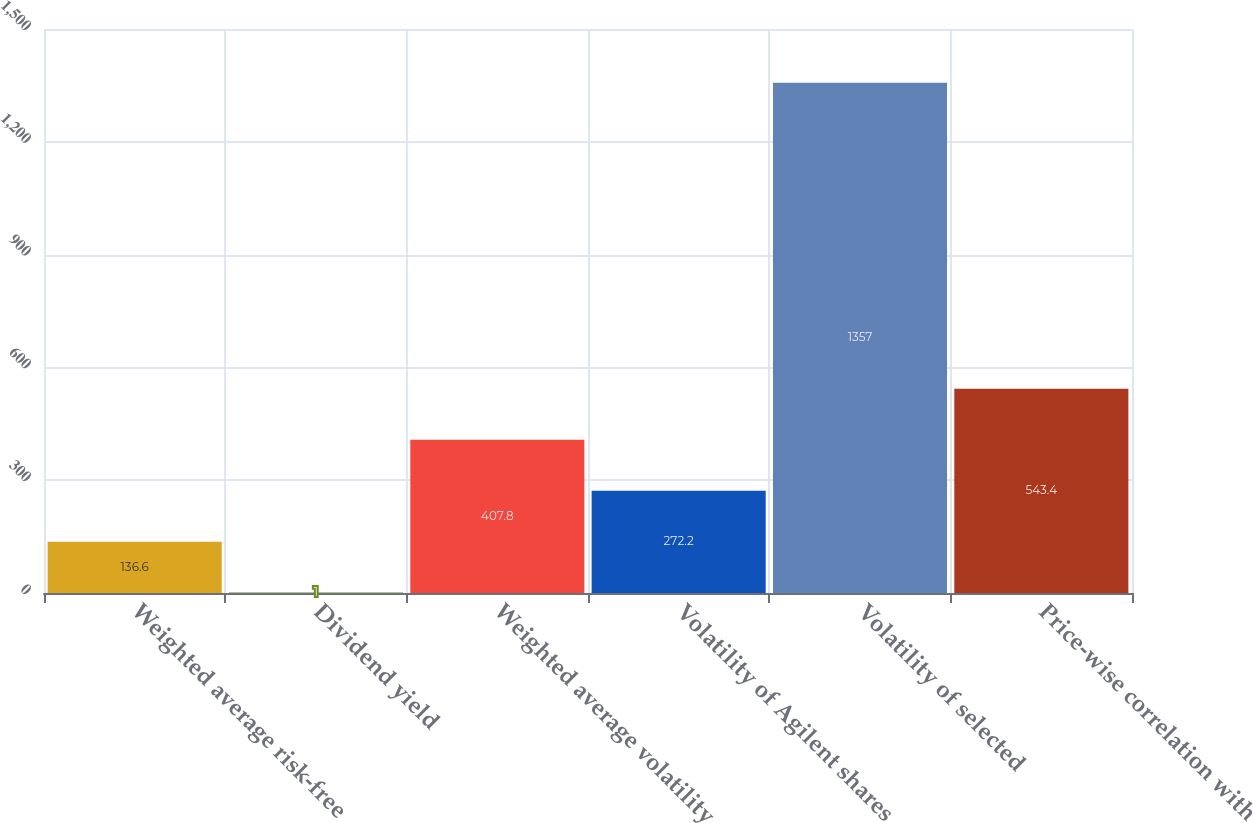<chart> <loc_0><loc_0><loc_500><loc_500><bar_chart><fcel>Weighted average risk-free<fcel>Dividend yield<fcel>Weighted average volatility<fcel>Volatility of Agilent shares<fcel>Volatility of selected<fcel>Price-wise correlation with<nl><fcel>136.6<fcel>1<fcel>407.8<fcel>272.2<fcel>1357<fcel>543.4<nl></chart> 